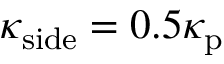<formula> <loc_0><loc_0><loc_500><loc_500>\kappa _ { s i d e } = 0 . 5 \kappa _ { p }</formula> 